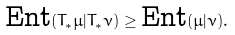Convert formula to latex. <formula><loc_0><loc_0><loc_500><loc_500>\text {Ent} ( T _ { * } \mu | T _ { * } \nu ) \geq \text {Ent} ( \mu | \nu ) .</formula> 